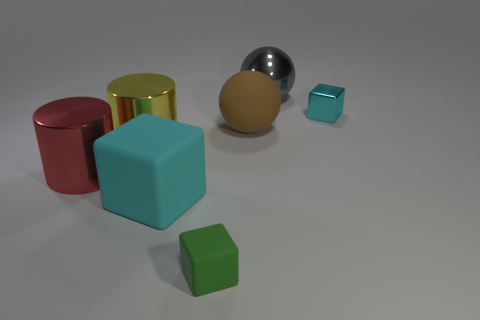There is another block that is the same color as the metallic cube; what is its material?
Offer a very short reply. Rubber. What number of other objects are the same material as the brown object?
Offer a terse response. 2. Is the shape of the big red thing the same as the metallic thing on the right side of the gray shiny object?
Make the answer very short. No. There is a big brown object that is the same material as the large cyan thing; what shape is it?
Provide a short and direct response. Sphere. Are there more shiny objects that are behind the gray metal ball than metallic cylinders to the left of the large red cylinder?
Your response must be concise. No. How many things are large brown matte objects or large cyan matte blocks?
Ensure brevity in your answer.  2. What number of other things are the same color as the tiny rubber thing?
Ensure brevity in your answer.  0. The yellow object that is the same size as the gray metallic object is what shape?
Offer a very short reply. Cylinder. There is a cylinder behind the red metallic cylinder; what color is it?
Your response must be concise. Yellow. How many objects are cubes that are behind the green cube or small cubes behind the big red cylinder?
Ensure brevity in your answer.  2. 